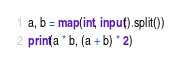<code> <loc_0><loc_0><loc_500><loc_500><_Python_>a, b = map(int, input().split())
print(a * b, (a + b) * 2)
</code> 